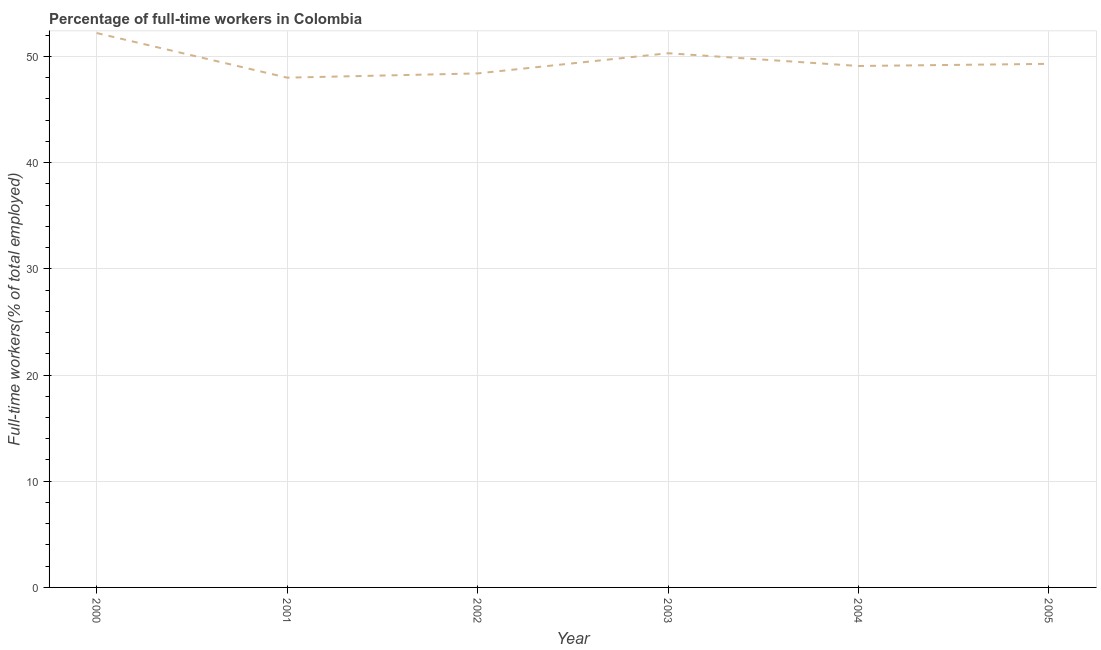What is the percentage of full-time workers in 2004?
Offer a terse response. 49.1. Across all years, what is the maximum percentage of full-time workers?
Your answer should be very brief. 52.2. Across all years, what is the minimum percentage of full-time workers?
Provide a succinct answer. 48. What is the sum of the percentage of full-time workers?
Your response must be concise. 297.3. What is the difference between the percentage of full-time workers in 2000 and 2005?
Make the answer very short. 2.9. What is the average percentage of full-time workers per year?
Your response must be concise. 49.55. What is the median percentage of full-time workers?
Give a very brief answer. 49.2. In how many years, is the percentage of full-time workers greater than 44 %?
Your answer should be very brief. 6. What is the ratio of the percentage of full-time workers in 2000 to that in 2002?
Provide a succinct answer. 1.08. What is the difference between the highest and the second highest percentage of full-time workers?
Your response must be concise. 1.9. Is the sum of the percentage of full-time workers in 2000 and 2005 greater than the maximum percentage of full-time workers across all years?
Provide a short and direct response. Yes. What is the difference between the highest and the lowest percentage of full-time workers?
Your response must be concise. 4.2. In how many years, is the percentage of full-time workers greater than the average percentage of full-time workers taken over all years?
Provide a succinct answer. 2. How many lines are there?
Give a very brief answer. 1. How many years are there in the graph?
Give a very brief answer. 6. What is the difference between two consecutive major ticks on the Y-axis?
Ensure brevity in your answer.  10. Does the graph contain any zero values?
Your answer should be very brief. No. What is the title of the graph?
Make the answer very short. Percentage of full-time workers in Colombia. What is the label or title of the Y-axis?
Your answer should be very brief. Full-time workers(% of total employed). What is the Full-time workers(% of total employed) in 2000?
Offer a very short reply. 52.2. What is the Full-time workers(% of total employed) of 2001?
Give a very brief answer. 48. What is the Full-time workers(% of total employed) in 2002?
Provide a succinct answer. 48.4. What is the Full-time workers(% of total employed) of 2003?
Offer a very short reply. 50.3. What is the Full-time workers(% of total employed) of 2004?
Ensure brevity in your answer.  49.1. What is the Full-time workers(% of total employed) of 2005?
Make the answer very short. 49.3. What is the difference between the Full-time workers(% of total employed) in 2000 and 2002?
Provide a succinct answer. 3.8. What is the difference between the Full-time workers(% of total employed) in 2001 and 2003?
Give a very brief answer. -2.3. What is the difference between the Full-time workers(% of total employed) in 2001 and 2004?
Make the answer very short. -1.1. What is the difference between the Full-time workers(% of total employed) in 2001 and 2005?
Provide a short and direct response. -1.3. What is the difference between the Full-time workers(% of total employed) in 2002 and 2003?
Your answer should be compact. -1.9. What is the difference between the Full-time workers(% of total employed) in 2003 and 2004?
Offer a terse response. 1.2. What is the difference between the Full-time workers(% of total employed) in 2003 and 2005?
Offer a terse response. 1. What is the ratio of the Full-time workers(% of total employed) in 2000 to that in 2001?
Offer a terse response. 1.09. What is the ratio of the Full-time workers(% of total employed) in 2000 to that in 2002?
Keep it short and to the point. 1.08. What is the ratio of the Full-time workers(% of total employed) in 2000 to that in 2003?
Provide a succinct answer. 1.04. What is the ratio of the Full-time workers(% of total employed) in 2000 to that in 2004?
Give a very brief answer. 1.06. What is the ratio of the Full-time workers(% of total employed) in 2000 to that in 2005?
Make the answer very short. 1.06. What is the ratio of the Full-time workers(% of total employed) in 2001 to that in 2002?
Make the answer very short. 0.99. What is the ratio of the Full-time workers(% of total employed) in 2001 to that in 2003?
Make the answer very short. 0.95. What is the ratio of the Full-time workers(% of total employed) in 2001 to that in 2005?
Keep it short and to the point. 0.97. What is the ratio of the Full-time workers(% of total employed) in 2002 to that in 2004?
Provide a short and direct response. 0.99. What is the ratio of the Full-time workers(% of total employed) in 2002 to that in 2005?
Make the answer very short. 0.98. What is the ratio of the Full-time workers(% of total employed) in 2003 to that in 2004?
Give a very brief answer. 1.02. What is the ratio of the Full-time workers(% of total employed) in 2003 to that in 2005?
Keep it short and to the point. 1.02. What is the ratio of the Full-time workers(% of total employed) in 2004 to that in 2005?
Ensure brevity in your answer.  1. 